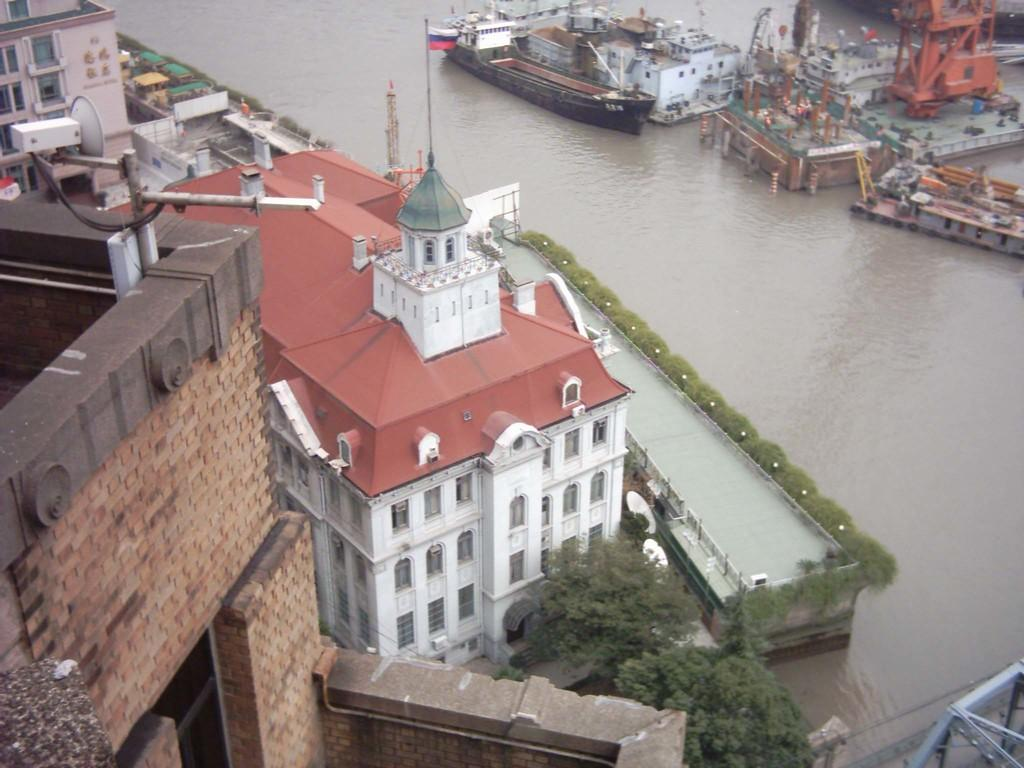What perspective is the image taken from? The image is taken from a top view. What can be seen in the middle of the image? There is water in the middle of the image. What types of watercraft are present in the water? There are ships and boats in the water. What structures are visible on the left side of the image? There are tall buildings on the left side of the image. What type of plants can be seen growing in the water in the image? There are no plants visible in the water in the image. 